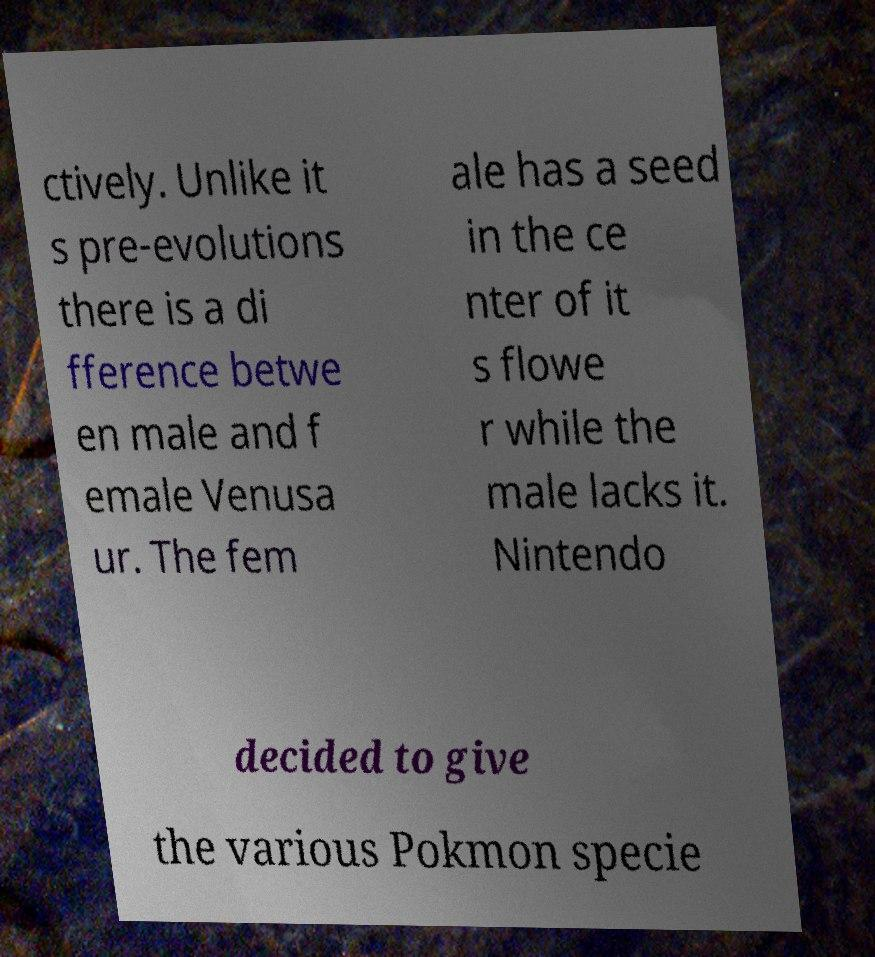Could you assist in decoding the text presented in this image and type it out clearly? ctively. Unlike it s pre-evolutions there is a di fference betwe en male and f emale Venusa ur. The fem ale has a seed in the ce nter of it s flowe r while the male lacks it. Nintendo decided to give the various Pokmon specie 